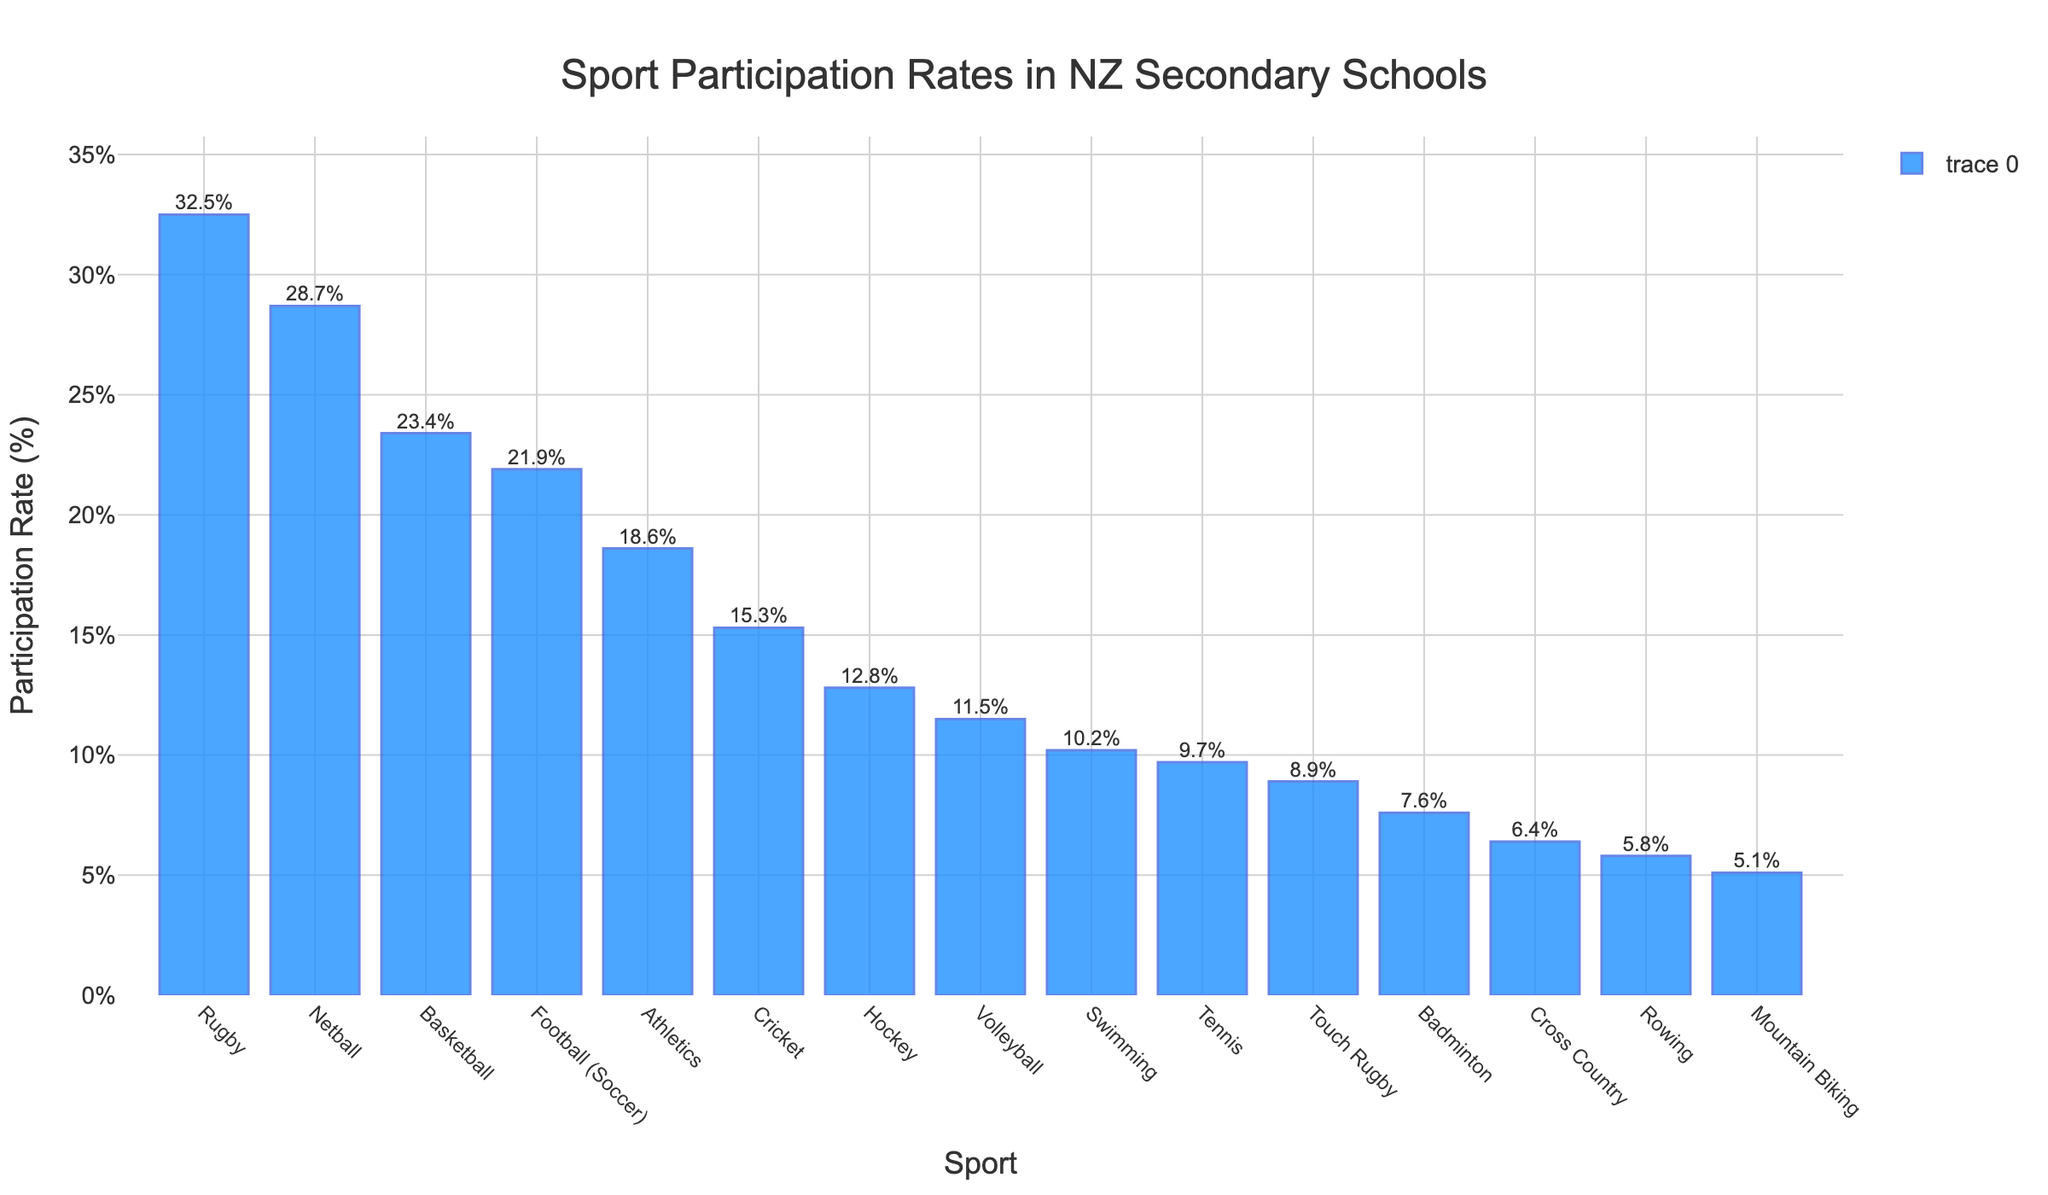Which sport has the highest participation rate? By looking at the heights of the bars in the chart, the bar for Rugby is the tallest, indicating the highest participation rate among the sports listed.
Answer: Rugby Which sport has a higher participation rate, Netball or Basketball? Comparing the heights of the bars for Netball and Basketball, Netball's bar is taller than Basketball's bar, indicating a higher participation rate.
Answer: Netball What is the total participation rate for Rugby, Netball, and Basketball combined? To find the total, sum the participation rates for Rugby (32.5%), Netball (28.7%), and Basketball (23.4%): 32.5% + 28.7% + 23.4% = 84.6%.
Answer: 84.6% Which sport is just below Rugby in terms of participation rate? By looking at the chart, the sport with the second-highest bar next to Rugby is Netball.
Answer: Netball How much higher is the participation rate for Rugby compared to Football (Soccer)? The participation rate for Rugby is 32.5%, and for Football (Soccer) it is 21.9%. Subtract Football's participation rate from Rugby's: 32.5% - 21.9% = 10.6%.
Answer: 10.6% Which sport has the lowest participation rate? Looking at the shortest bar in the chart, Mountain Biking has the lowest participation rate.
Answer: Mountain Biking What is the average participation rate for Athletics, Cricket, and Hockey? To find the average, sum the participation rates for Athletics (18.6%), Cricket (15.3%), and Hockey (12.8%), then divide by 3: (18.6% + 15.3% + 12.8%) / 3 = 15.567%.
Answer: 15.6% Which two sports have participation rates closest to each other? By comparing the heights of the bars, Tennis and Touch Rugby have very similar heights, indicating close participation rates: Tennis with 9.7% and Touch Rugby with 8.9%.
Answer: Tennis and Touch Rugby What is the difference in participation rates between the highest and lowest sports? The highest participation rate is for Rugby at 32.5%, and the lowest is for Mountain Biking at 5.1%. Subtract Mountain Biking's rate from Rugby's: 32.5% - 5.1% = 27.4%.
Answer: 27.4% How many sports have a participation rate below 10%? Count the bars that represent a participation rate below 10%: Swimming, Tennis, Touch Rugby, Badminton, Cross Country, Rowing, and Mountain Biking, which total to 7 sports.
Answer: 7 